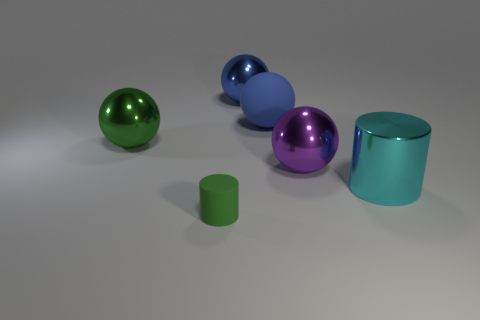Add 1 small yellow rubber spheres. How many objects exist? 7 Subtract all spheres. How many objects are left? 2 Add 2 big green spheres. How many big green spheres are left? 3 Add 1 big objects. How many big objects exist? 6 Subtract 0 blue cubes. How many objects are left? 6 Subtract all big cyan rubber things. Subtract all big blue metal objects. How many objects are left? 5 